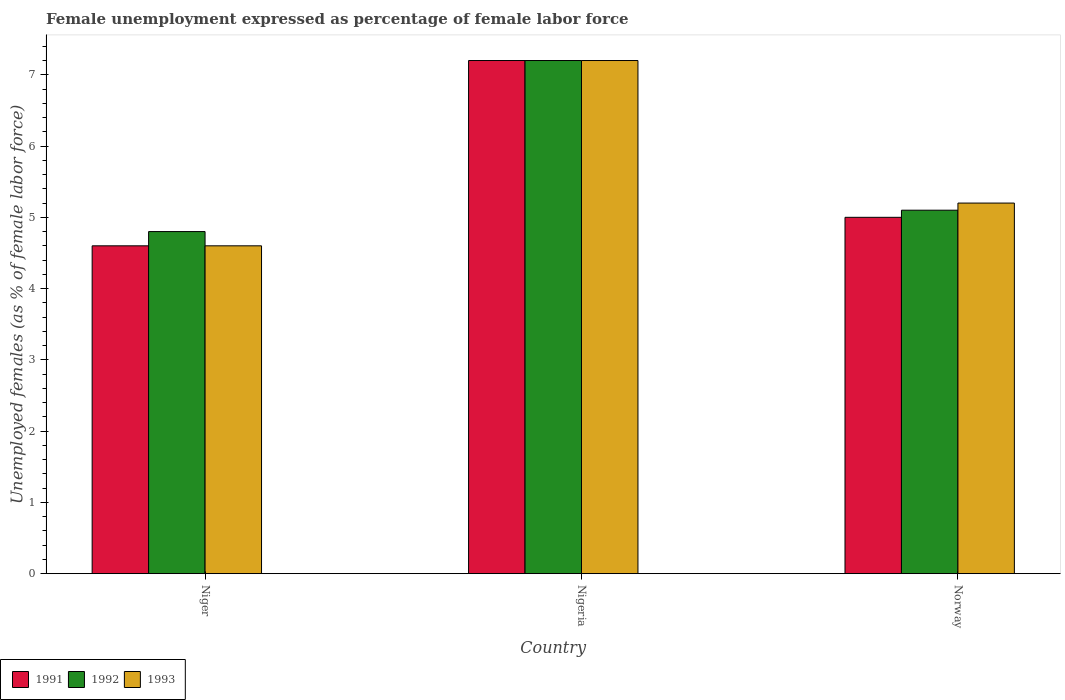Are the number of bars on each tick of the X-axis equal?
Offer a very short reply. Yes. What is the label of the 1st group of bars from the left?
Your answer should be very brief. Niger. In how many cases, is the number of bars for a given country not equal to the number of legend labels?
Offer a very short reply. 0. What is the unemployment in females in in 1993 in Nigeria?
Offer a terse response. 7.2. Across all countries, what is the maximum unemployment in females in in 1993?
Your answer should be compact. 7.2. Across all countries, what is the minimum unemployment in females in in 1992?
Make the answer very short. 4.8. In which country was the unemployment in females in in 1993 maximum?
Keep it short and to the point. Nigeria. In which country was the unemployment in females in in 1991 minimum?
Your response must be concise. Niger. What is the total unemployment in females in in 1991 in the graph?
Your answer should be very brief. 16.8. What is the difference between the unemployment in females in in 1993 in Niger and that in Norway?
Make the answer very short. -0.6. What is the difference between the unemployment in females in in 1993 in Nigeria and the unemployment in females in in 1992 in Norway?
Give a very brief answer. 2.1. What is the average unemployment in females in in 1993 per country?
Provide a succinct answer. 5.67. What is the difference between the unemployment in females in of/in 1993 and unemployment in females in of/in 1991 in Norway?
Provide a succinct answer. 0.2. What is the ratio of the unemployment in females in in 1993 in Nigeria to that in Norway?
Keep it short and to the point. 1.38. Is the difference between the unemployment in females in in 1993 in Niger and Nigeria greater than the difference between the unemployment in females in in 1991 in Niger and Nigeria?
Your response must be concise. No. What is the difference between the highest and the second highest unemployment in females in in 1991?
Give a very brief answer. -0.4. What is the difference between the highest and the lowest unemployment in females in in 1992?
Ensure brevity in your answer.  2.4. In how many countries, is the unemployment in females in in 1992 greater than the average unemployment in females in in 1992 taken over all countries?
Give a very brief answer. 1. Is the sum of the unemployment in females in in 1993 in Nigeria and Norway greater than the maximum unemployment in females in in 1992 across all countries?
Offer a very short reply. Yes. What does the 3rd bar from the left in Nigeria represents?
Ensure brevity in your answer.  1993. What does the 2nd bar from the right in Niger represents?
Ensure brevity in your answer.  1992. Are all the bars in the graph horizontal?
Offer a very short reply. No. How many countries are there in the graph?
Ensure brevity in your answer.  3. Are the values on the major ticks of Y-axis written in scientific E-notation?
Your answer should be compact. No. Does the graph contain any zero values?
Ensure brevity in your answer.  No. Where does the legend appear in the graph?
Offer a terse response. Bottom left. How many legend labels are there?
Offer a very short reply. 3. How are the legend labels stacked?
Give a very brief answer. Horizontal. What is the title of the graph?
Keep it short and to the point. Female unemployment expressed as percentage of female labor force. Does "2012" appear as one of the legend labels in the graph?
Provide a succinct answer. No. What is the label or title of the X-axis?
Keep it short and to the point. Country. What is the label or title of the Y-axis?
Provide a succinct answer. Unemployed females (as % of female labor force). What is the Unemployed females (as % of female labor force) in 1991 in Niger?
Your answer should be very brief. 4.6. What is the Unemployed females (as % of female labor force) in 1992 in Niger?
Your answer should be compact. 4.8. What is the Unemployed females (as % of female labor force) in 1993 in Niger?
Keep it short and to the point. 4.6. What is the Unemployed females (as % of female labor force) in 1991 in Nigeria?
Offer a terse response. 7.2. What is the Unemployed females (as % of female labor force) of 1992 in Nigeria?
Make the answer very short. 7.2. What is the Unemployed females (as % of female labor force) of 1993 in Nigeria?
Your answer should be compact. 7.2. What is the Unemployed females (as % of female labor force) of 1991 in Norway?
Ensure brevity in your answer.  5. What is the Unemployed females (as % of female labor force) of 1992 in Norway?
Offer a very short reply. 5.1. What is the Unemployed females (as % of female labor force) in 1993 in Norway?
Give a very brief answer. 5.2. Across all countries, what is the maximum Unemployed females (as % of female labor force) in 1991?
Your response must be concise. 7.2. Across all countries, what is the maximum Unemployed females (as % of female labor force) of 1992?
Provide a succinct answer. 7.2. Across all countries, what is the maximum Unemployed females (as % of female labor force) of 1993?
Provide a succinct answer. 7.2. Across all countries, what is the minimum Unemployed females (as % of female labor force) in 1991?
Your answer should be compact. 4.6. Across all countries, what is the minimum Unemployed females (as % of female labor force) in 1992?
Make the answer very short. 4.8. Across all countries, what is the minimum Unemployed females (as % of female labor force) in 1993?
Your answer should be compact. 4.6. What is the total Unemployed females (as % of female labor force) of 1991 in the graph?
Offer a terse response. 16.8. What is the total Unemployed females (as % of female labor force) of 1993 in the graph?
Your answer should be very brief. 17. What is the difference between the Unemployed females (as % of female labor force) of 1992 in Niger and that in Nigeria?
Make the answer very short. -2.4. What is the difference between the Unemployed females (as % of female labor force) of 1993 in Niger and that in Nigeria?
Provide a succinct answer. -2.6. What is the difference between the Unemployed females (as % of female labor force) of 1993 in Niger and that in Norway?
Your answer should be compact. -0.6. What is the difference between the Unemployed females (as % of female labor force) in 1991 in Nigeria and that in Norway?
Your answer should be very brief. 2.2. What is the difference between the Unemployed females (as % of female labor force) of 1993 in Nigeria and that in Norway?
Keep it short and to the point. 2. What is the difference between the Unemployed females (as % of female labor force) of 1991 in Niger and the Unemployed females (as % of female labor force) of 1993 in Nigeria?
Your answer should be very brief. -2.6. What is the difference between the Unemployed females (as % of female labor force) in 1992 in Niger and the Unemployed females (as % of female labor force) in 1993 in Nigeria?
Give a very brief answer. -2.4. What is the difference between the Unemployed females (as % of female labor force) in 1991 in Niger and the Unemployed females (as % of female labor force) in 1993 in Norway?
Offer a terse response. -0.6. What is the difference between the Unemployed females (as % of female labor force) of 1992 in Niger and the Unemployed females (as % of female labor force) of 1993 in Norway?
Offer a terse response. -0.4. What is the difference between the Unemployed females (as % of female labor force) in 1991 in Nigeria and the Unemployed females (as % of female labor force) in 1992 in Norway?
Give a very brief answer. 2.1. What is the difference between the Unemployed females (as % of female labor force) of 1992 in Nigeria and the Unemployed females (as % of female labor force) of 1993 in Norway?
Give a very brief answer. 2. What is the average Unemployed females (as % of female labor force) in 1992 per country?
Your response must be concise. 5.7. What is the average Unemployed females (as % of female labor force) of 1993 per country?
Make the answer very short. 5.67. What is the difference between the Unemployed females (as % of female labor force) in 1991 and Unemployed females (as % of female labor force) in 1992 in Niger?
Your answer should be compact. -0.2. What is the difference between the Unemployed females (as % of female labor force) in 1991 and Unemployed females (as % of female labor force) in 1993 in Norway?
Your response must be concise. -0.2. What is the difference between the Unemployed females (as % of female labor force) of 1992 and Unemployed females (as % of female labor force) of 1993 in Norway?
Give a very brief answer. -0.1. What is the ratio of the Unemployed females (as % of female labor force) of 1991 in Niger to that in Nigeria?
Offer a terse response. 0.64. What is the ratio of the Unemployed females (as % of female labor force) of 1992 in Niger to that in Nigeria?
Your answer should be compact. 0.67. What is the ratio of the Unemployed females (as % of female labor force) of 1993 in Niger to that in Nigeria?
Keep it short and to the point. 0.64. What is the ratio of the Unemployed females (as % of female labor force) in 1992 in Niger to that in Norway?
Offer a terse response. 0.94. What is the ratio of the Unemployed females (as % of female labor force) of 1993 in Niger to that in Norway?
Provide a succinct answer. 0.88. What is the ratio of the Unemployed females (as % of female labor force) in 1991 in Nigeria to that in Norway?
Your response must be concise. 1.44. What is the ratio of the Unemployed females (as % of female labor force) of 1992 in Nigeria to that in Norway?
Offer a very short reply. 1.41. What is the ratio of the Unemployed females (as % of female labor force) of 1993 in Nigeria to that in Norway?
Provide a short and direct response. 1.38. What is the difference between the highest and the second highest Unemployed females (as % of female labor force) of 1991?
Make the answer very short. 2.2. What is the difference between the highest and the second highest Unemployed females (as % of female labor force) of 1992?
Make the answer very short. 2.1. What is the difference between the highest and the second highest Unemployed females (as % of female labor force) in 1993?
Offer a terse response. 2. What is the difference between the highest and the lowest Unemployed females (as % of female labor force) in 1992?
Offer a very short reply. 2.4. What is the difference between the highest and the lowest Unemployed females (as % of female labor force) of 1993?
Your answer should be very brief. 2.6. 